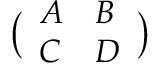<formula> <loc_0><loc_0><loc_500><loc_500>\left ( \begin{array} { l l } { A } & { B } \\ { C } & { D } \end{array} \right )</formula> 